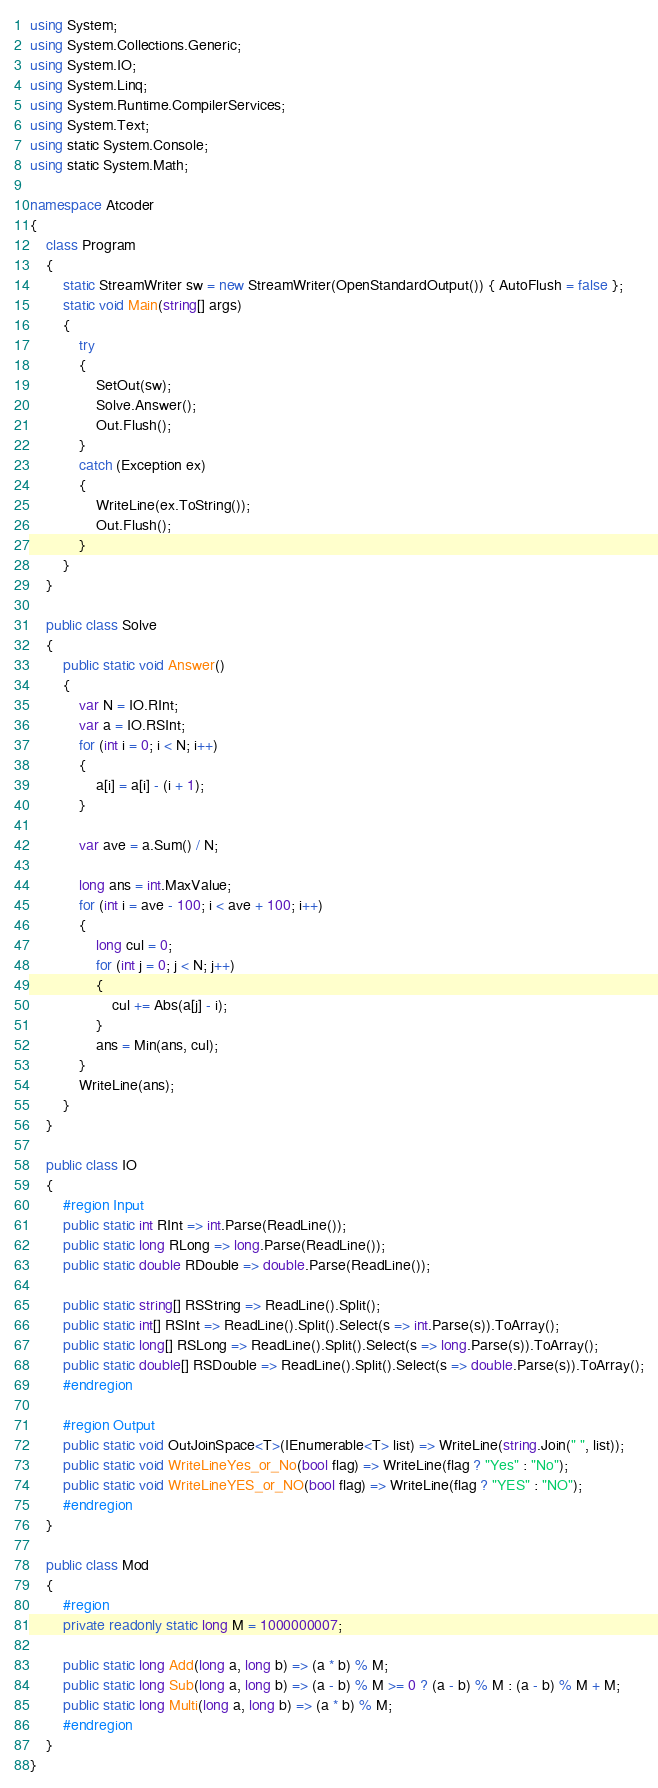Convert code to text. <code><loc_0><loc_0><loc_500><loc_500><_C#_>using System;
using System.Collections.Generic;
using System.IO;
using System.Linq;
using System.Runtime.CompilerServices;
using System.Text;
using static System.Console;
using static System.Math;

namespace Atcoder
{
    class Program
    {
        static StreamWriter sw = new StreamWriter(OpenStandardOutput()) { AutoFlush = false };
        static void Main(string[] args)
        {
            try
            {
                SetOut(sw);
                Solve.Answer();
                Out.Flush();
            }
            catch (Exception ex)
            {
                WriteLine(ex.ToString());
                Out.Flush();
            }
        }
    }

    public class Solve
    {
        public static void Answer()
        {
            var N = IO.RInt;
            var a = IO.RSInt;
            for (int i = 0; i < N; i++)
            {
                a[i] = a[i] - (i + 1);
            }

            var ave = a.Sum() / N;

            long ans = int.MaxValue;
            for (int i = ave - 100; i < ave + 100; i++)
            {
                long cul = 0;
                for (int j = 0; j < N; j++)
                {
                    cul += Abs(a[j] - i);
                }
                ans = Min(ans, cul);
            }
            WriteLine(ans);
        }
    }

    public class IO
    {
        #region Input
        public static int RInt => int.Parse(ReadLine());
        public static long RLong => long.Parse(ReadLine());
        public static double RDouble => double.Parse(ReadLine());

        public static string[] RSString => ReadLine().Split();
        public static int[] RSInt => ReadLine().Split().Select(s => int.Parse(s)).ToArray();
        public static long[] RSLong => ReadLine().Split().Select(s => long.Parse(s)).ToArray();
        public static double[] RSDouble => ReadLine().Split().Select(s => double.Parse(s)).ToArray();
        #endregion

        #region Output
        public static void OutJoinSpace<T>(IEnumerable<T> list) => WriteLine(string.Join(" ", list));
        public static void WriteLineYes_or_No(bool flag) => WriteLine(flag ? "Yes" : "No");
        public static void WriteLineYES_or_NO(bool flag) => WriteLine(flag ? "YES" : "NO");
        #endregion
    }

    public class Mod
    {
        #region
        private readonly static long M = 1000000007;

        public static long Add(long a, long b) => (a * b) % M;
        public static long Sub(long a, long b) => (a - b) % M >= 0 ? (a - b) % M : (a - b) % M + M;
        public static long Multi(long a, long b) => (a * b) % M;
        #endregion
    }
}</code> 